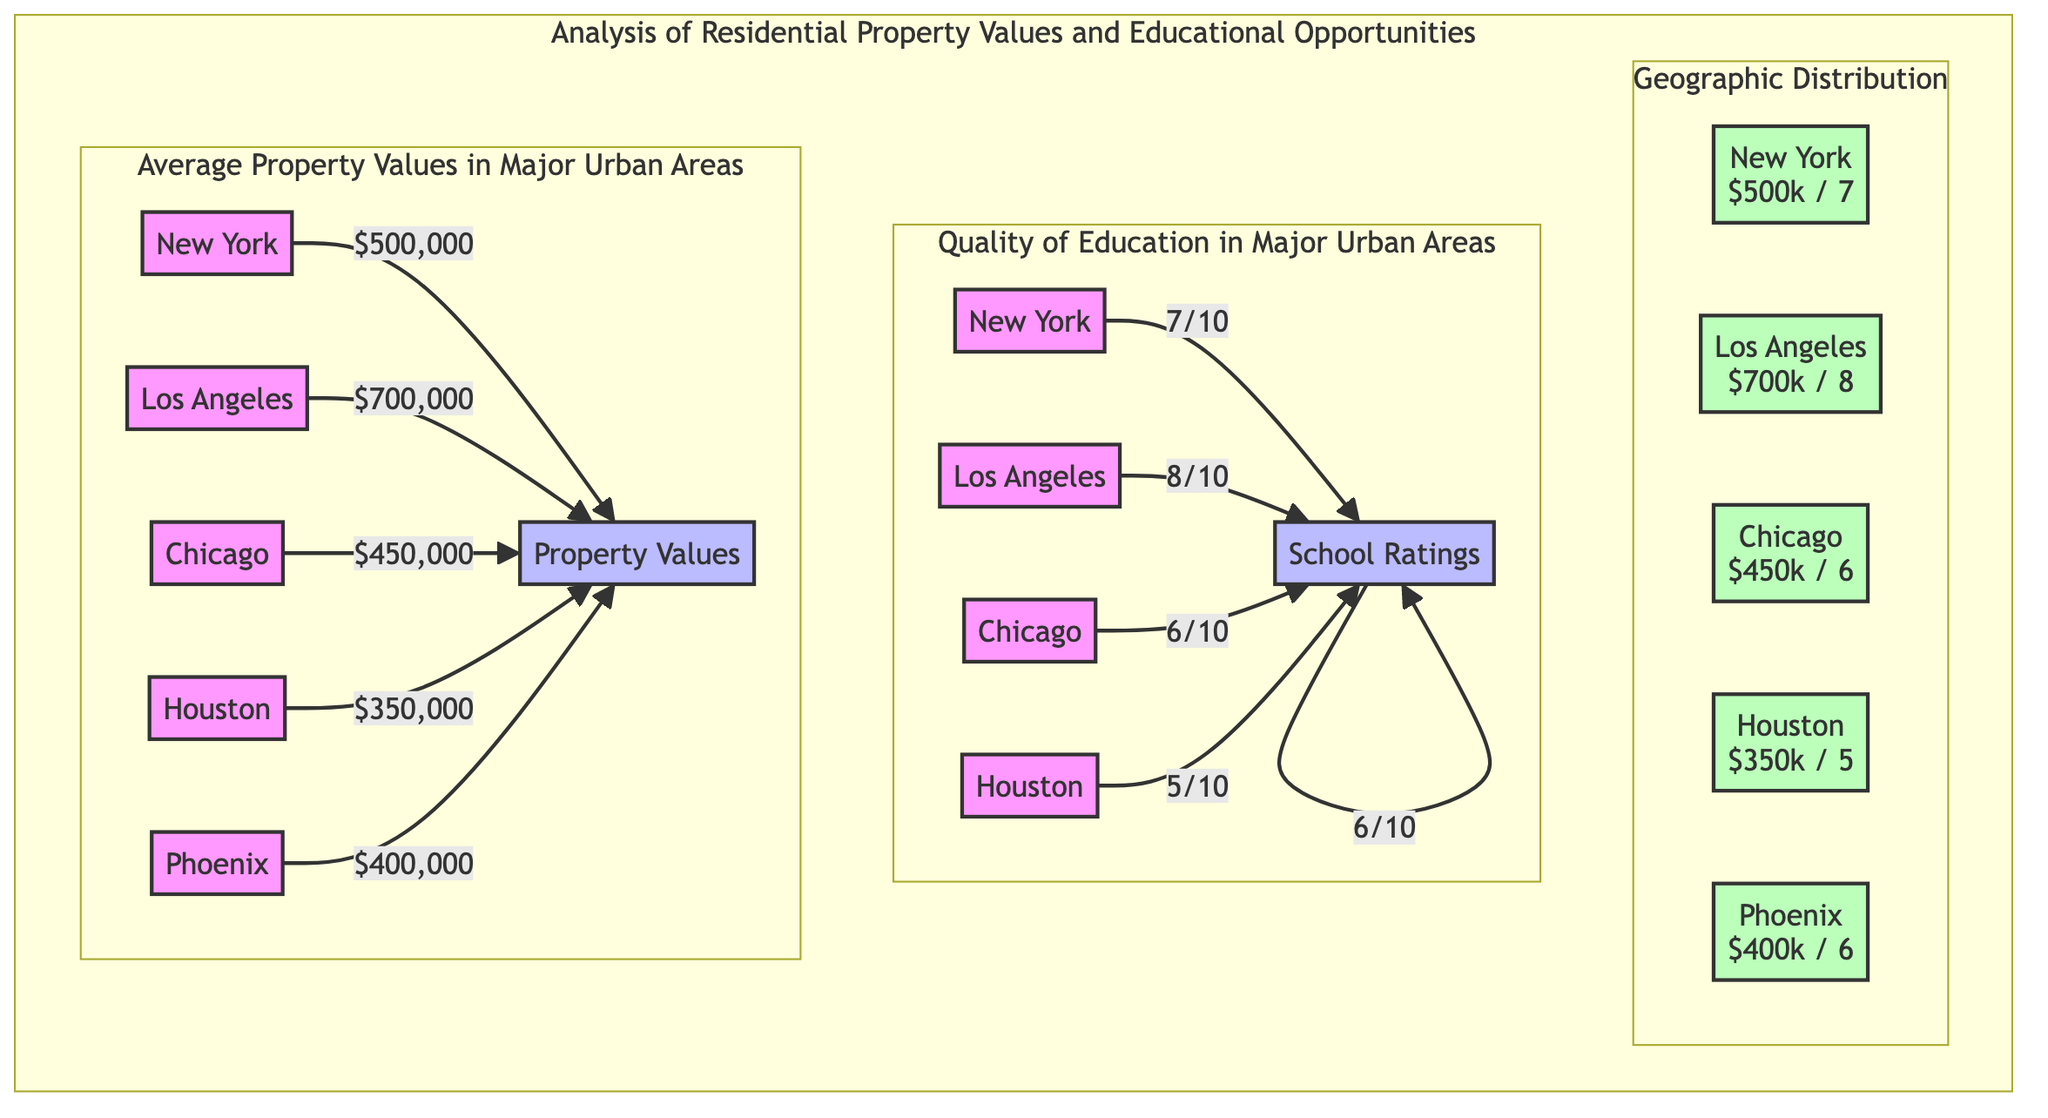What is the average property value in Los Angeles? The diagram indicates that the average property value in Los Angeles is represented as $700,000 directly connected to the node representing Los Angeles.
Answer: $700,000 Which city has the highest quality of education rating? By comparing the educational ratings provided for the cities, Los Angeles has the highest quality rating at 8/10.
Answer: 8/10 What is the property value for Houston? The diagram specifies that the property value for Houston is $350,000, directly associated with its node.
Answer: $350,000 How many cities are represented in the diagram? The diagram lists five cities: New York, Los Angeles, Chicago, Houston, and Phoenix. Therefore, the total number of cities is five.
Answer: 5 What is the relationship between Chicago's property value and education quality? Chicago's property value is $450,000 and its education quality rating is 6/10. Comparing these, we see Chicago has a moderate property value and a lower educational quality compared to Los Angeles.
Answer: Moderate property value and lower educational quality Which city's property value is closest to the average value of all represented cities? To find the average of the property values ($500,000 + $700,000 + $450,000 + $350,000 + $400,000 = $2,400,000) and divide by 5 equals $480,000. The closest property value is Chicago's at $450,000, which is the nearest to the calculated average.
Answer: Chicago What is the geographic distribution diagram indicating about the educational ratings overall? The geographic distribution shows the ratings alongside property values. Overall, the educational ratings range from 5 to 8 out of 10, indicating variations in opportunity based on location.
Answer: Variations in opportunity based on location Which city has a property value less than $400,000? By examining the properties, Houston has a property value of $350,000, which is less than $400,000.
Answer: Houston 